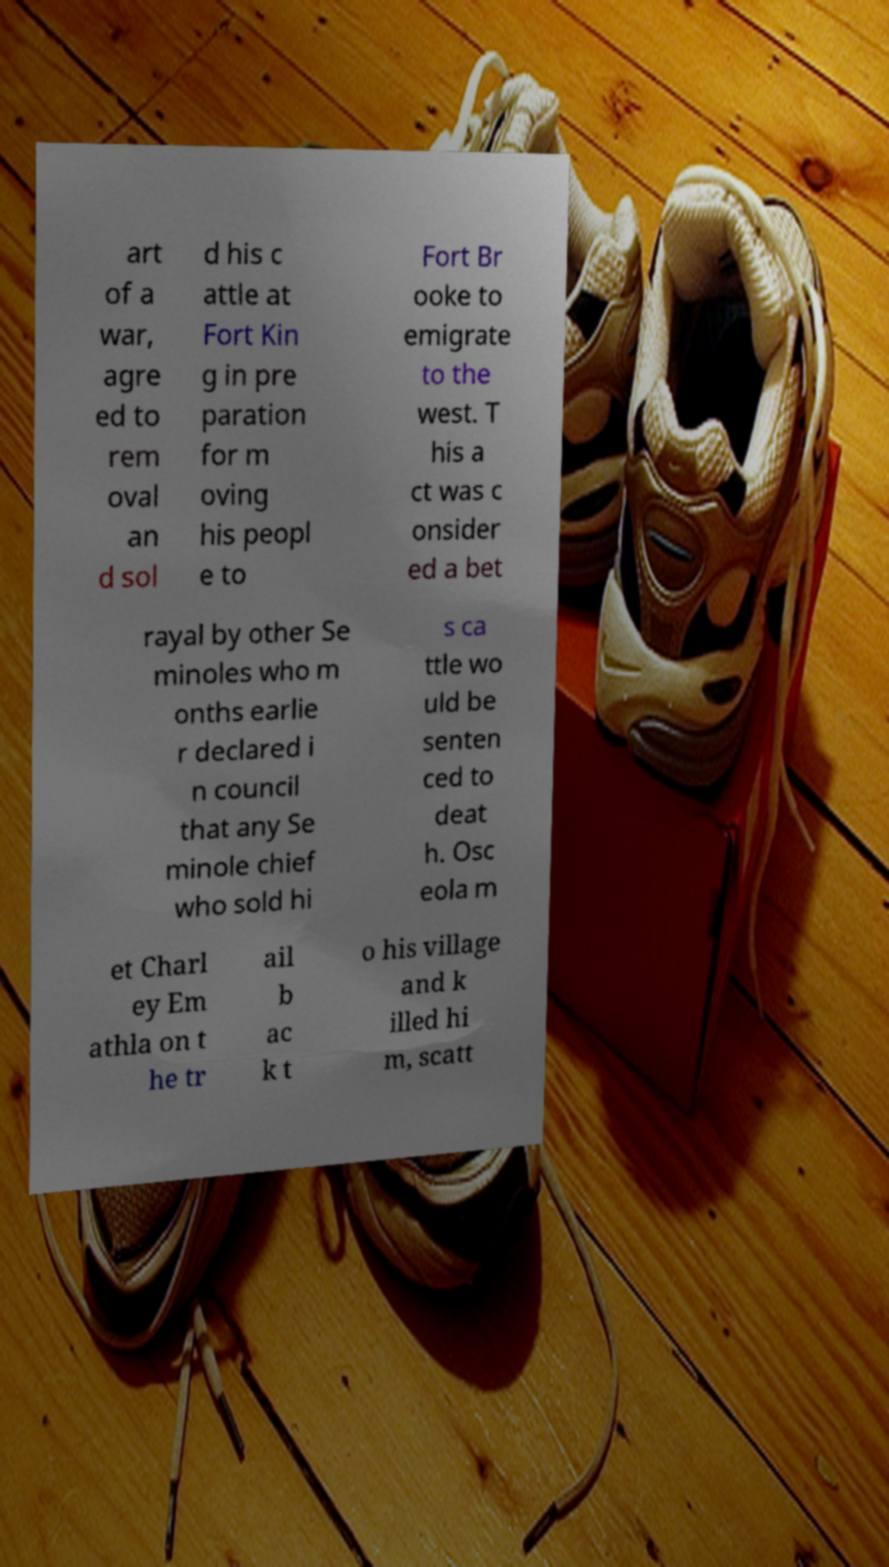Could you extract and type out the text from this image? art of a war, agre ed to rem oval an d sol d his c attle at Fort Kin g in pre paration for m oving his peopl e to Fort Br ooke to emigrate to the west. T his a ct was c onsider ed a bet rayal by other Se minoles who m onths earlie r declared i n council that any Se minole chief who sold hi s ca ttle wo uld be senten ced to deat h. Osc eola m et Charl ey Em athla on t he tr ail b ac k t o his village and k illed hi m, scatt 